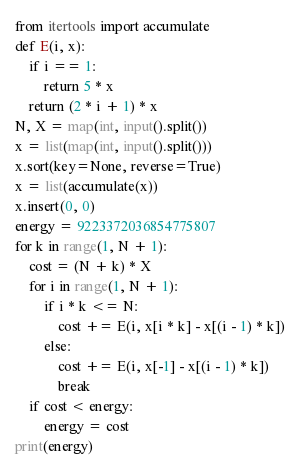<code> <loc_0><loc_0><loc_500><loc_500><_Python_>from itertools import accumulate
def E(i, x):
    if i == 1:
        return 5 * x
    return (2 * i + 1) * x
N, X = map(int, input().split())
x = list(map(int, input().split()))
x.sort(key=None, reverse=True)
x = list(accumulate(x))
x.insert(0, 0)
energy = 9223372036854775807
for k in range(1, N + 1):
    cost = (N + k) * X
    for i in range(1, N + 1):
        if i * k <= N:
            cost += E(i, x[i * k] - x[(i - 1) * k])
        else:
            cost += E(i, x[-1] - x[(i - 1) * k])
            break
    if cost < energy:
        energy = cost
print(energy)
</code> 